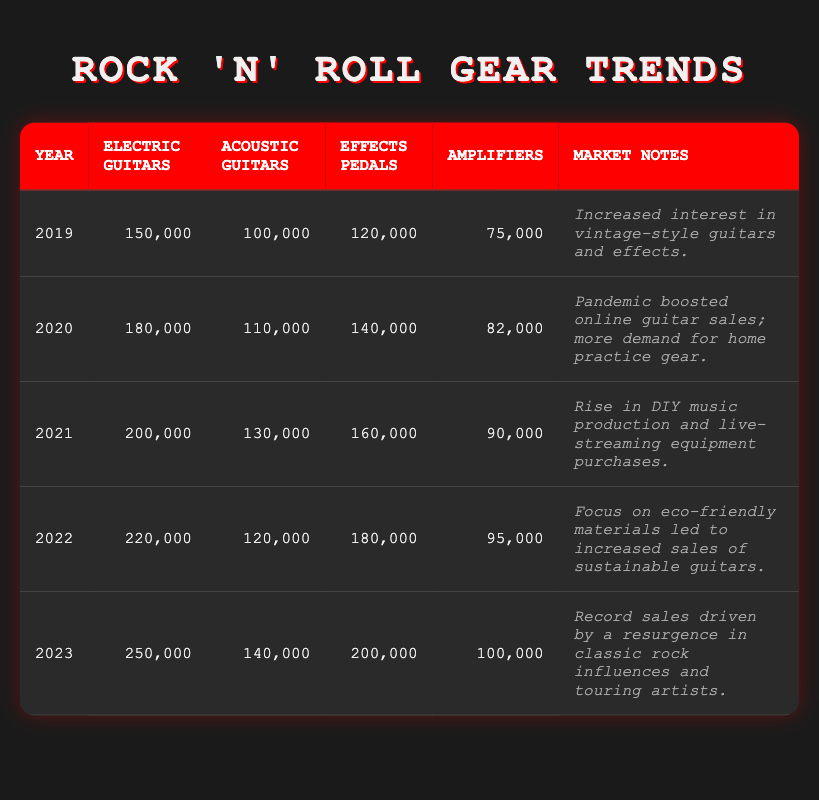What was the total number of Electric and Acoustic guitars sold in 2022? In 2022, Electric Guitars sold amounted to 220,000, while Acoustic Guitars sold totaled 120,000. To find the total, we add these two values: 220,000 + 120,000 = 340,000.
Answer: 340,000 In which year did the sales of Effects Pedals reach the highest value? The table shows that Effects Pedals sales were highest in 2023 with a total of 200,000 units sold, compared to 180,000 in 2022.
Answer: 2023 How many more Electric Guitars were sold in 2021 compared to 2019? For 2019, Electric Guitars sold were 150,000, and in 2021, they increased to 200,000. To find the difference, we subtract: 200,000 - 150,000 = 50,000.
Answer: 50,000 What was the trend in Acoustic Guitar sales from 2019 to 2023? In 2019, 100,000 Acoustic Guitars were sold, increasing to 140,000 in 2023. To summarize the trend: from 2019 to 2023, sales consistently increased except for a slight dip in 2022 with 120,000 units sold. Overall, the trend shows growth over the years.
Answer: Increasing trend overall Was there a higher increase in Amplifier sales from 2021 to 2023 or from 2019 to 2021? Sales of Amplifiers in 2021 were 90,000, and by 2023, they had risen to 100,000, which is an increase of 10,000. From 2019 (75,000) to 2021 (90,000), the increase was 15,000. Therefore, the increase from 2019 to 2021 was higher (15,000) than from 2021 to 2023 (10,000).
Answer: Higher increase from 2019 to 2021 What was the average number of Electric Guitars sold over the five years? To find the average, we sum the Electric Guitars sold from 2019 (150,000), 2020 (180,000), 2021 (200,000), 2022 (220,000), and 2023 (250,000). The total is 1,000,000. Then, we divide by 5 (the number of years): 1,000,000 / 5 = 200,000.
Answer: 200,000 Which year had the highest number of Acoustic Guitars sold? In the year 2023, Acoustic Guitars sold were at 140,000, which is higher compared to previous years: 100,000 in 2019, 110,000 in 2020, 130,000 in 2021, and 120,000 in 2022. Thus, 2023 had the highest sales of Acoustic Guitars.
Answer: 2023 Did the market show a consistent rise in sales of Effects Pedals from 2019 to 2023? The sales figures were 120,000 in 2019, 140,000 in 2020, 160,000 in 2021, 180,000 in 2022, and finally 200,000 in 2023. Since the sales increased every year without any decrease, we can say that there was consistent growth.
Answer: Yes, consistent rise What was the percentage increase in Electric Guitars sold from 2020 to 2021? To calculate the percentage increase, we take the difference between 2021 (200,000) and 2020 (180,000), which is 20,000. We then divide this difference by the 2020 sales: (20,000 / 180,000) * 100 = 11.11%.
Answer: 11.11% How would you describe the overall trend for amplifiers in the years analyzed? The sales figures for amplifiers are 75,000 in 2019, 82,000 in 2020, 90,000 in 2021, 95,000 in 2022, and 100,000 in 2023. The sales increased each year, so the overall trend is upward.
Answer: Upward trend 